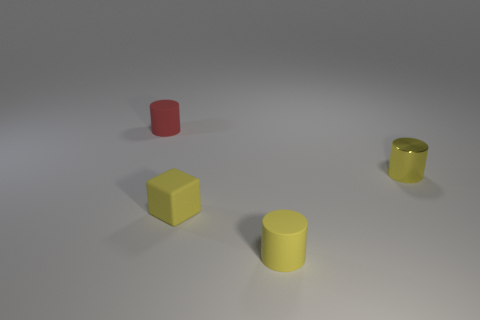How many small yellow things are on the left side of the small yellow metal thing and on the right side of the cube?
Your response must be concise. 1. What material is the yellow thing in front of the small yellow block in front of the tiny yellow shiny object made of?
Your response must be concise. Rubber. There is a red object that is the same shape as the yellow metallic object; what is its material?
Make the answer very short. Rubber. Is there a cylinder?
Your response must be concise. Yes. There is a small red object that is the same material as the small yellow block; what shape is it?
Your answer should be very brief. Cylinder. There is a tiny yellow cylinder that is in front of the rubber block; what is it made of?
Provide a succinct answer. Rubber. Does the matte thing behind the tiny shiny object have the same color as the tiny cube?
Provide a succinct answer. No. What is the size of the cylinder left of the tiny rubber cylinder in front of the red thing?
Provide a succinct answer. Small. Is the number of yellow shiny cylinders in front of the yellow metallic cylinder greater than the number of big brown things?
Your answer should be compact. No. Is the size of the matte cylinder in front of the red rubber cylinder the same as the red object?
Your answer should be very brief. Yes. 